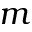<formula> <loc_0><loc_0><loc_500><loc_500>m</formula> 